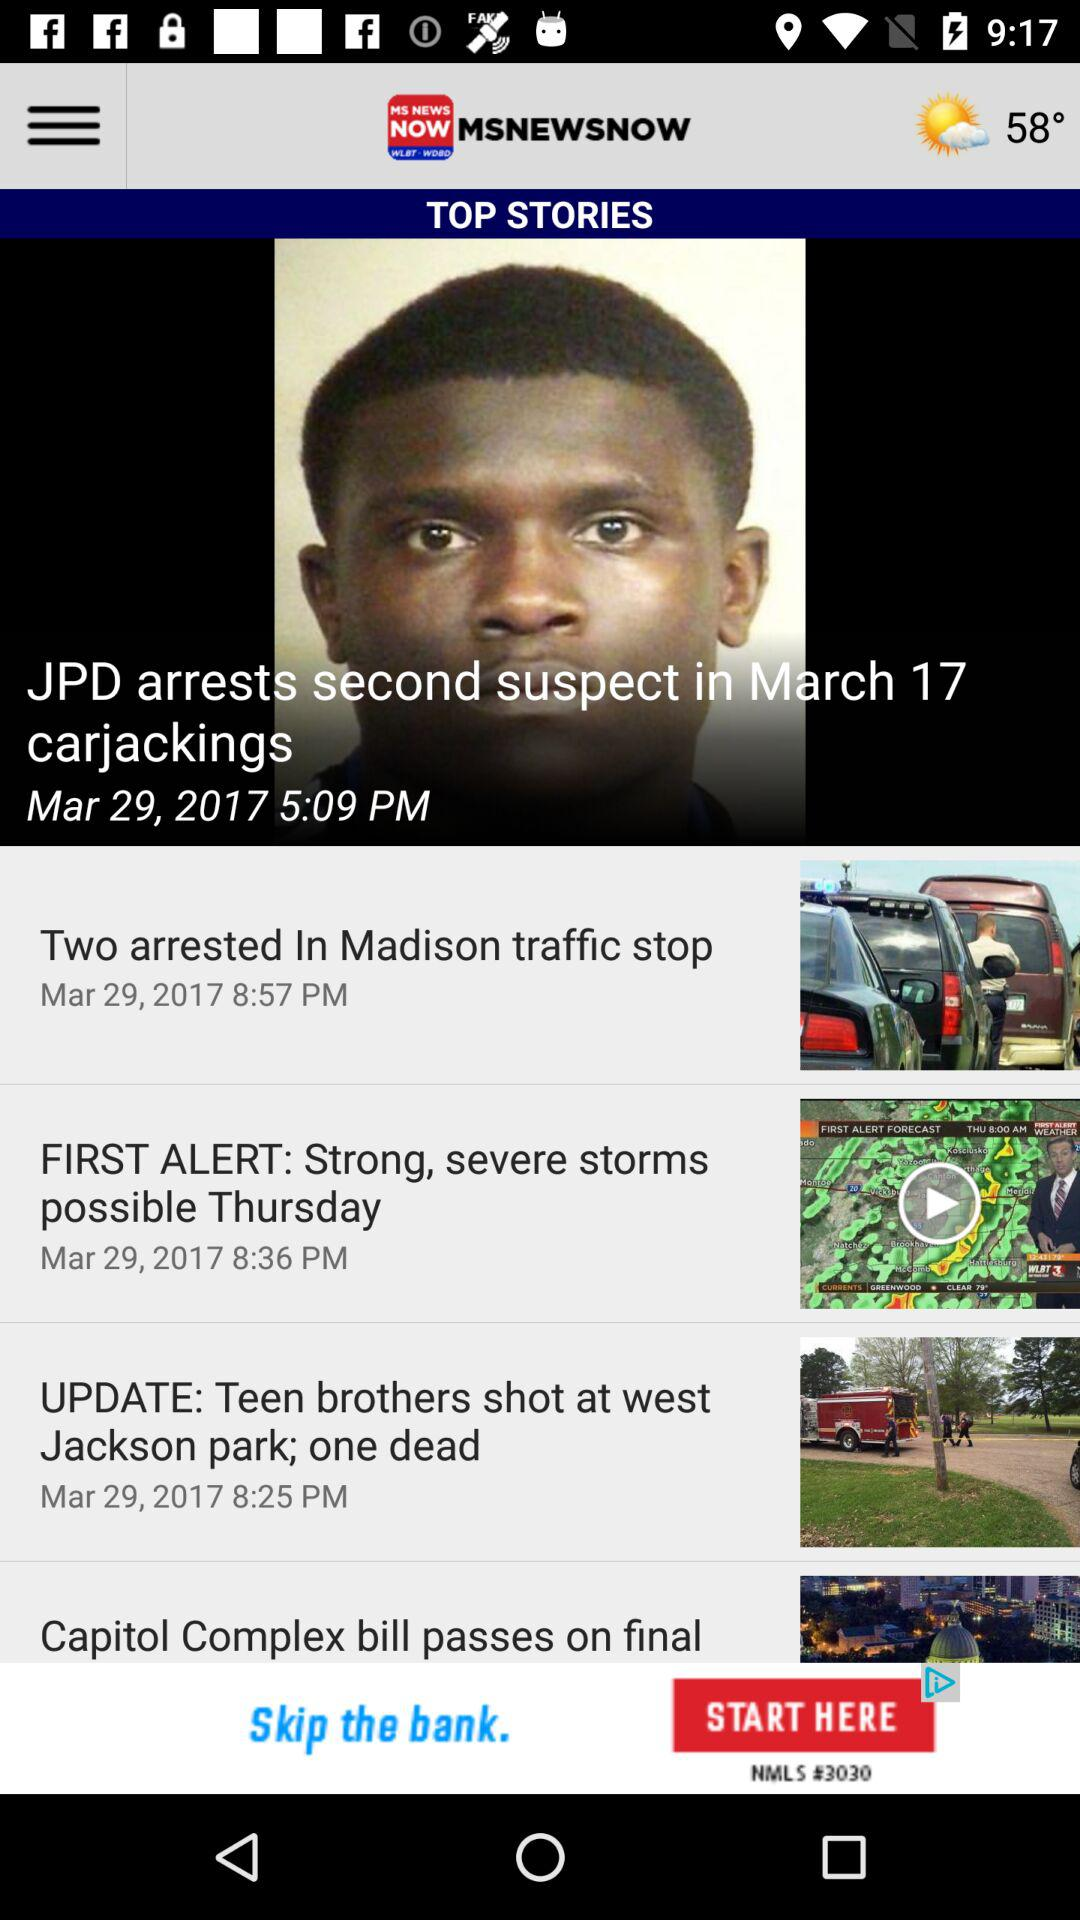What is the temperature? The temperature is 58°. 